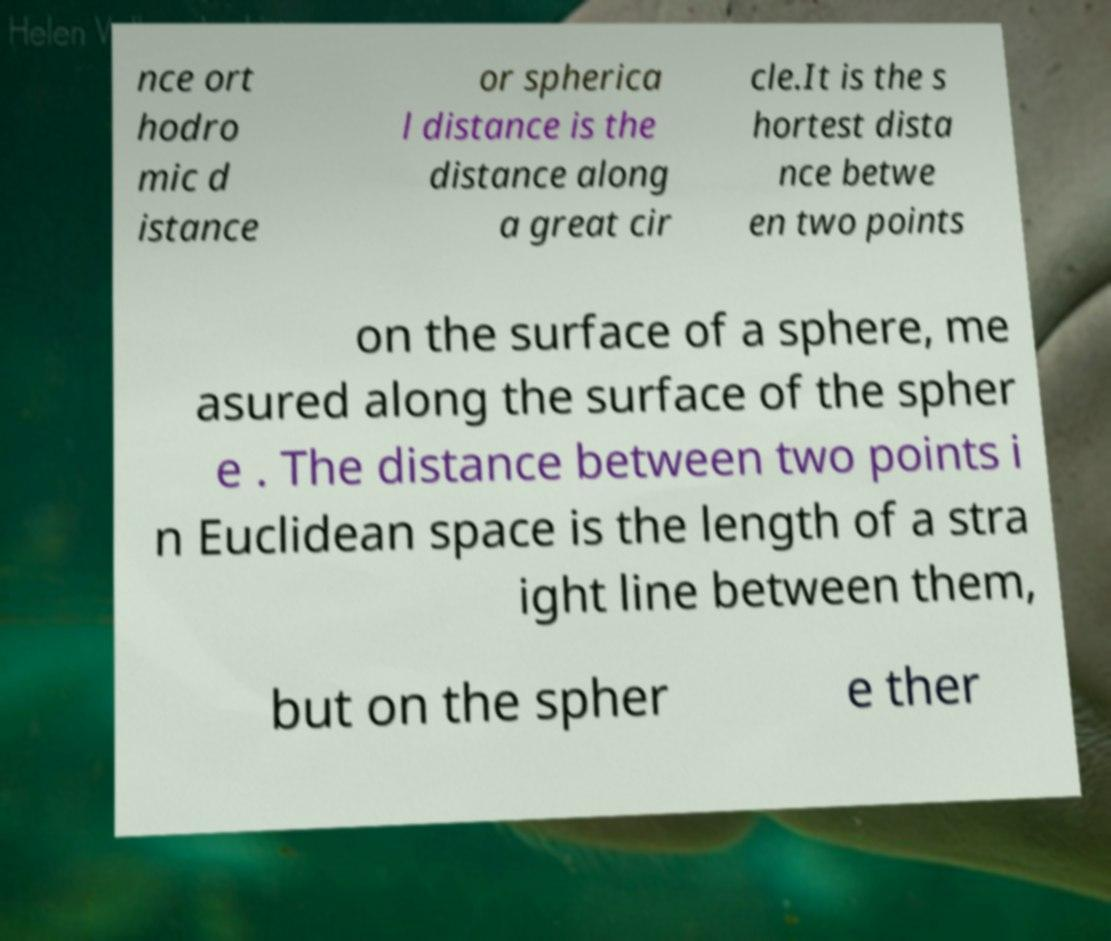Could you assist in decoding the text presented in this image and type it out clearly? nce ort hodro mic d istance or spherica l distance is the distance along a great cir cle.It is the s hortest dista nce betwe en two points on the surface of a sphere, me asured along the surface of the spher e . The distance between two points i n Euclidean space is the length of a stra ight line between them, but on the spher e ther 